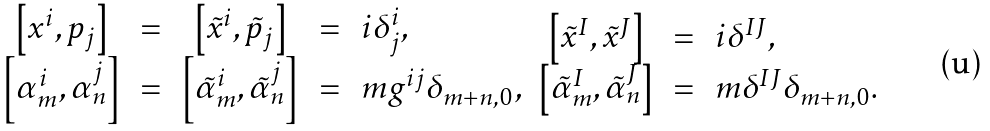<formula> <loc_0><loc_0><loc_500><loc_500>\begin{array} { c c c c l } \left [ x ^ { i } , p _ { j } \right ] & \, = \, & \left [ \tilde { x } ^ { i } , \tilde { p } _ { j } \right ] & \, = \, & i \delta ^ { i } _ { j } , \\ \left [ \alpha _ { m } ^ { i } , \alpha _ { n } ^ { j } \right ] & \, = \, & \left [ \tilde { \alpha } _ { m } ^ { i } , \tilde { \alpha } _ { n } ^ { j } \right ] & \, = \, & m g ^ { i j } \delta _ { m + n , 0 } , \end{array} \begin{array} { c c l } \left [ \tilde { x } ^ { I } , \tilde { x } ^ { J } \right ] & \, = \, & i \delta ^ { I J } , \\ \left [ \tilde { \alpha } _ { m } ^ { I } , \tilde { \alpha } _ { n } ^ { J } \right ] & \, = \, & m \delta ^ { I J } \delta _ { m + n , 0 } . \end{array}</formula> 